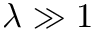Convert formula to latex. <formula><loc_0><loc_0><loc_500><loc_500>\lambda \gg 1</formula> 